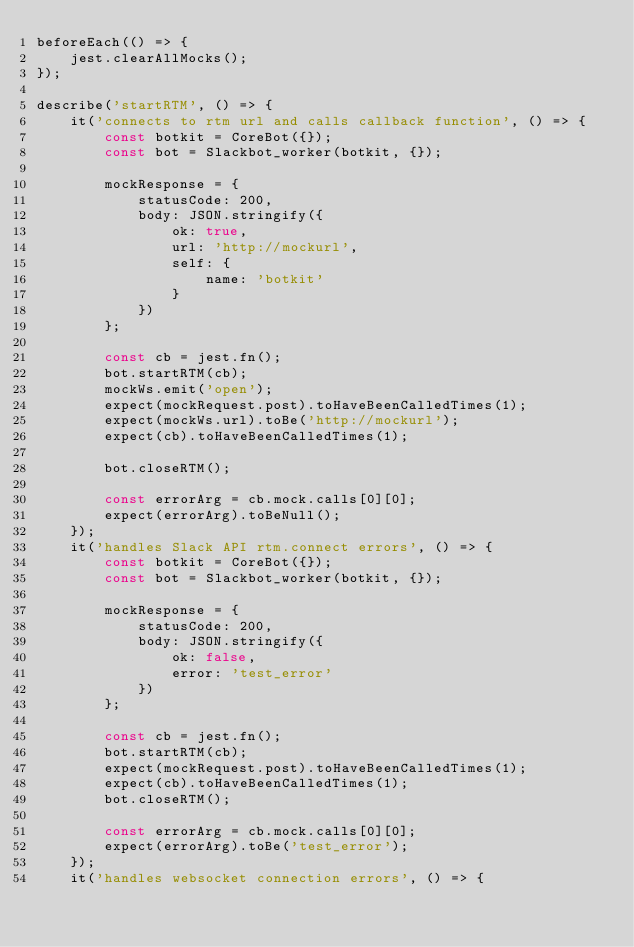Convert code to text. <code><loc_0><loc_0><loc_500><loc_500><_JavaScript_>beforeEach(() => {
    jest.clearAllMocks();
});

describe('startRTM', () => {
    it('connects to rtm url and calls callback function', () => {
        const botkit = CoreBot({});
        const bot = Slackbot_worker(botkit, {});

        mockResponse = {
            statusCode: 200,
            body: JSON.stringify({
                ok: true,
                url: 'http://mockurl',
                self: {
                    name: 'botkit'
                }
            })
        };

        const cb = jest.fn();
        bot.startRTM(cb);
        mockWs.emit('open');
        expect(mockRequest.post).toHaveBeenCalledTimes(1);
        expect(mockWs.url).toBe('http://mockurl');
        expect(cb).toHaveBeenCalledTimes(1);

        bot.closeRTM();

        const errorArg = cb.mock.calls[0][0];
        expect(errorArg).toBeNull();
    });
    it('handles Slack API rtm.connect errors', () => {
        const botkit = CoreBot({});
        const bot = Slackbot_worker(botkit, {});

        mockResponse = {
            statusCode: 200,
            body: JSON.stringify({
                ok: false,
                error: 'test_error'
            })
        };

        const cb = jest.fn();
        bot.startRTM(cb);
        expect(mockRequest.post).toHaveBeenCalledTimes(1);
        expect(cb).toHaveBeenCalledTimes(1);
        bot.closeRTM();

        const errorArg = cb.mock.calls[0][0];
        expect(errorArg).toBe('test_error');
    });
    it('handles websocket connection errors', () => {</code> 